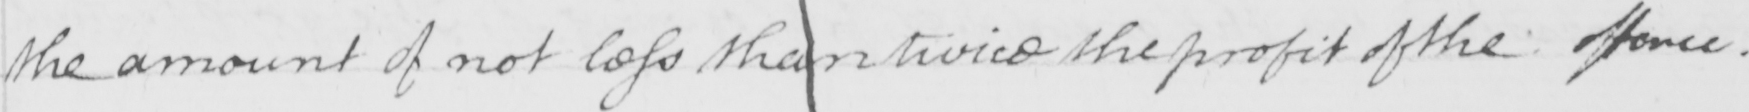Can you read and transcribe this handwriting? the amount of not less than twice the profit of the offence . 